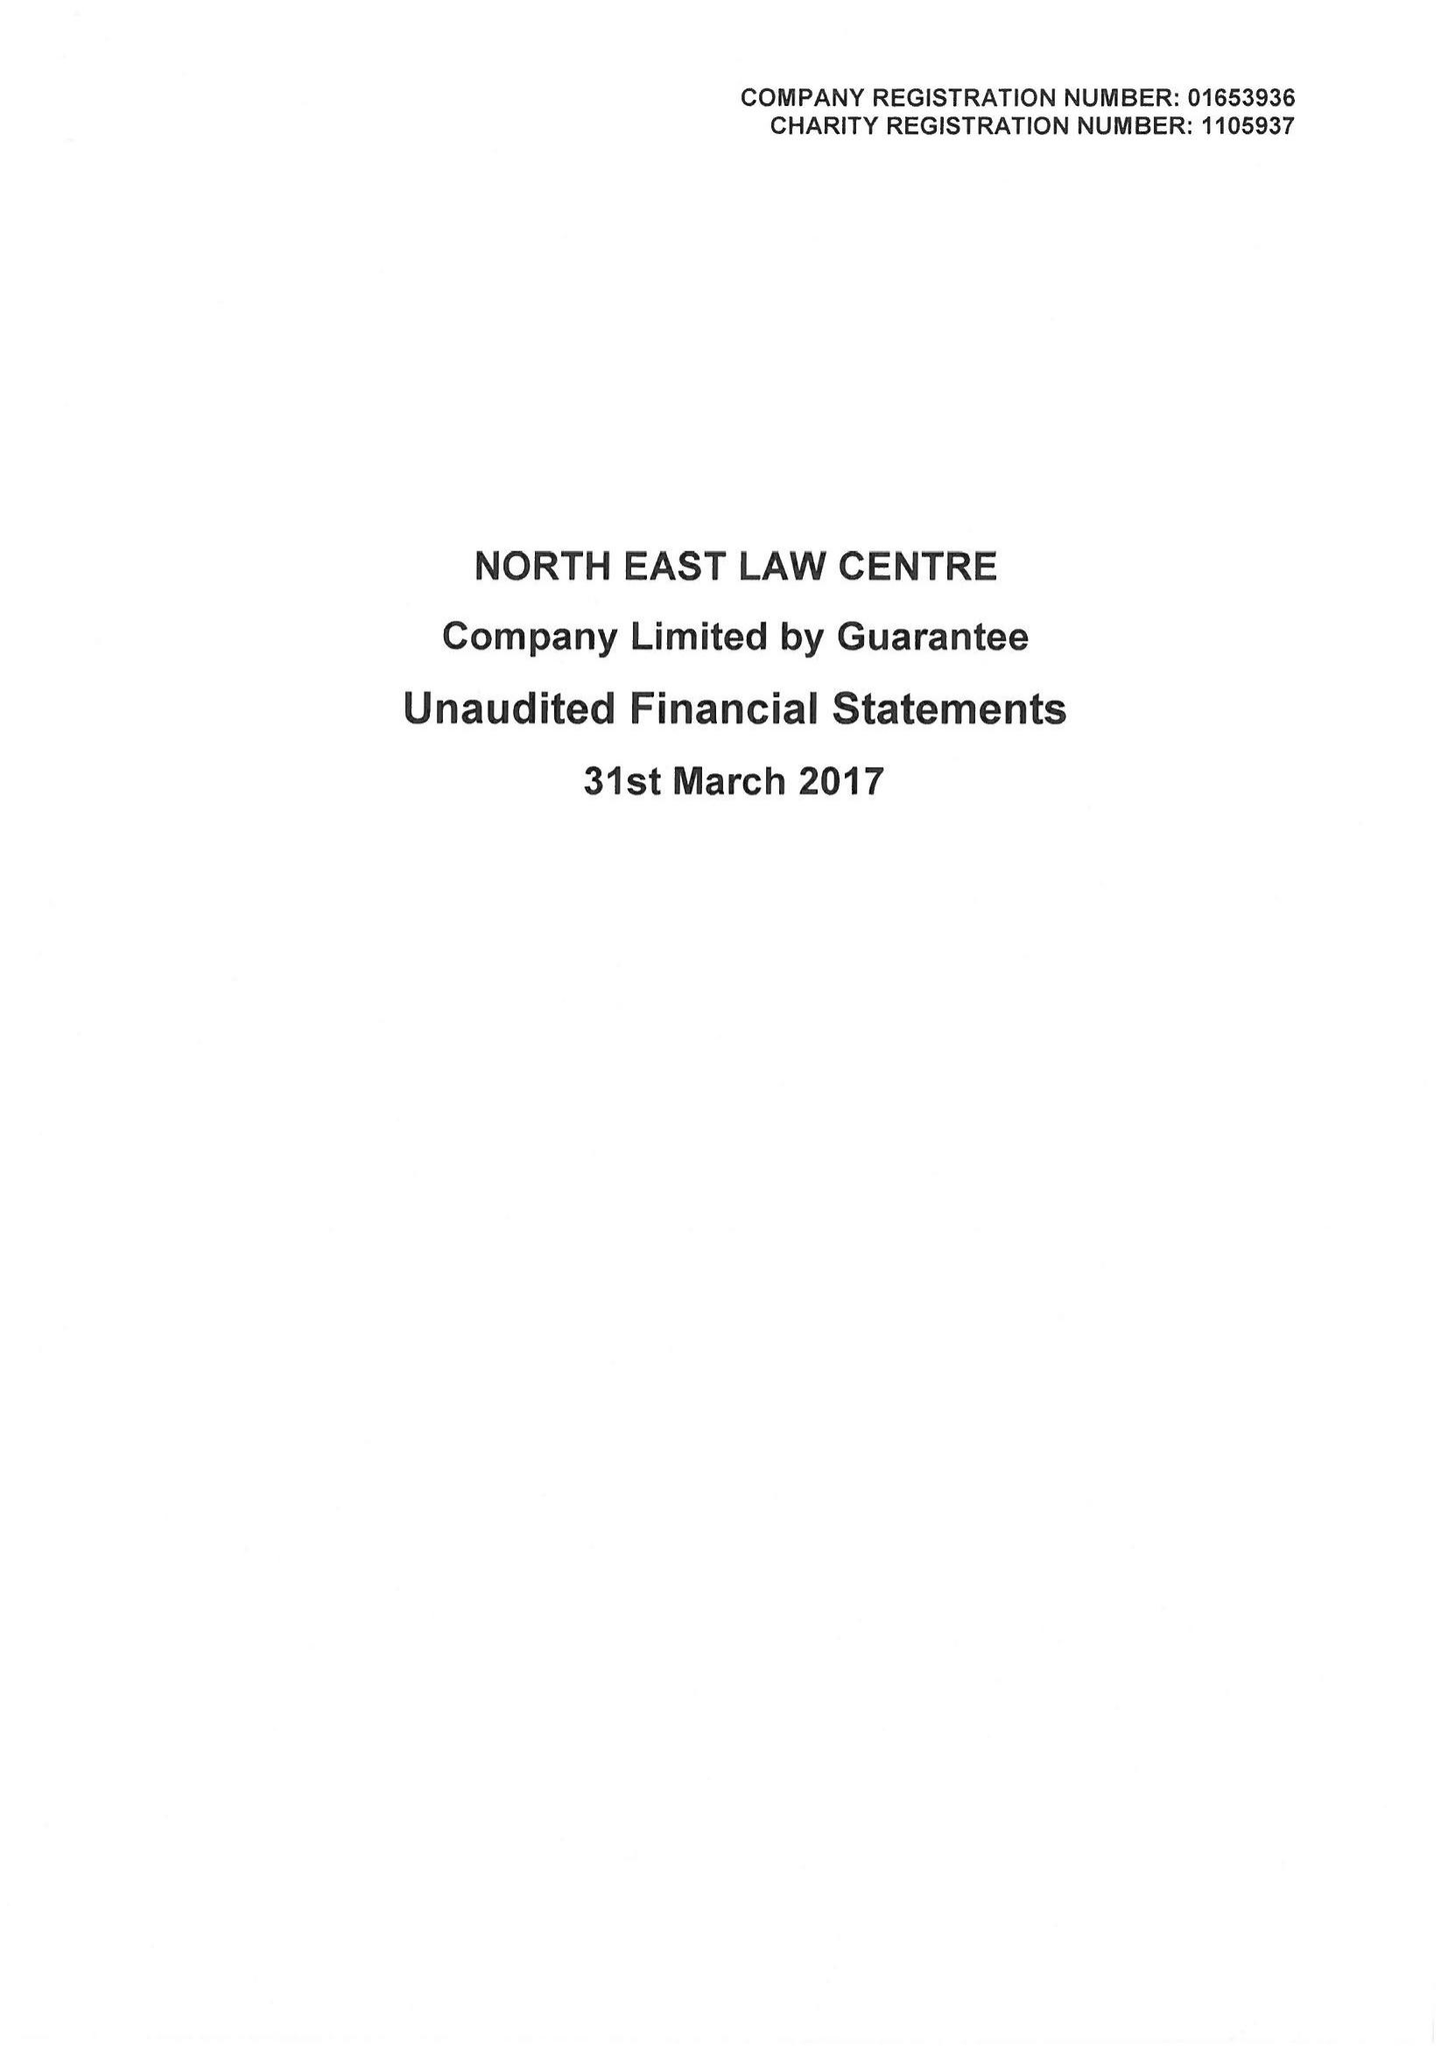What is the value for the address__post_town?
Answer the question using a single word or phrase. NEWCASTLE UPON TYNE 